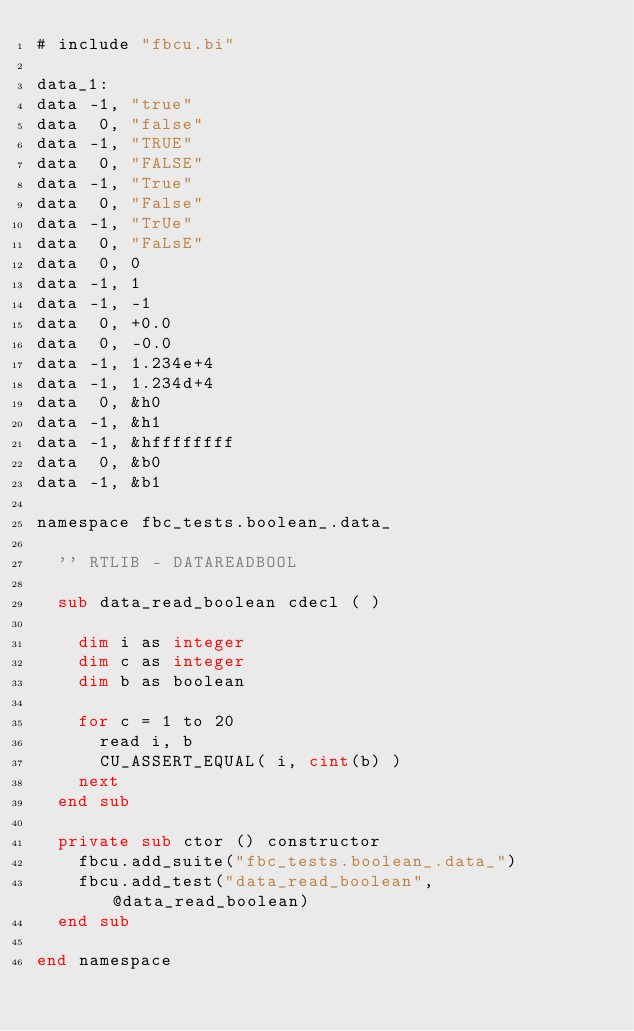Convert code to text. <code><loc_0><loc_0><loc_500><loc_500><_VisualBasic_># include "fbcu.bi"

data_1:
data -1, "true"
data  0, "false"
data -1, "TRUE"
data  0, "FALSE"
data -1, "True"
data  0, "False"
data -1, "TrUe"
data  0, "FaLsE"
data  0, 0
data -1, 1
data -1, -1
data  0, +0.0
data  0, -0.0
data -1, 1.234e+4
data -1, 1.234d+4
data  0, &h0
data -1, &h1
data -1, &hffffffff
data  0, &b0
data -1, &b1

namespace fbc_tests.boolean_.data_

	'' RTLIB - DATAREADBOOL

	sub data_read_boolean cdecl ( )
		
		dim i as integer
		dim c as integer
		dim b as boolean

		for c = 1 to 20
			read i, b
			CU_ASSERT_EQUAL( i, cint(b) )
		next
	end sub

	private sub ctor () constructor
		fbcu.add_suite("fbc_tests.boolean_.data_")
		fbcu.add_test("data_read_boolean", @data_read_boolean)
	end sub

end namespace
</code> 